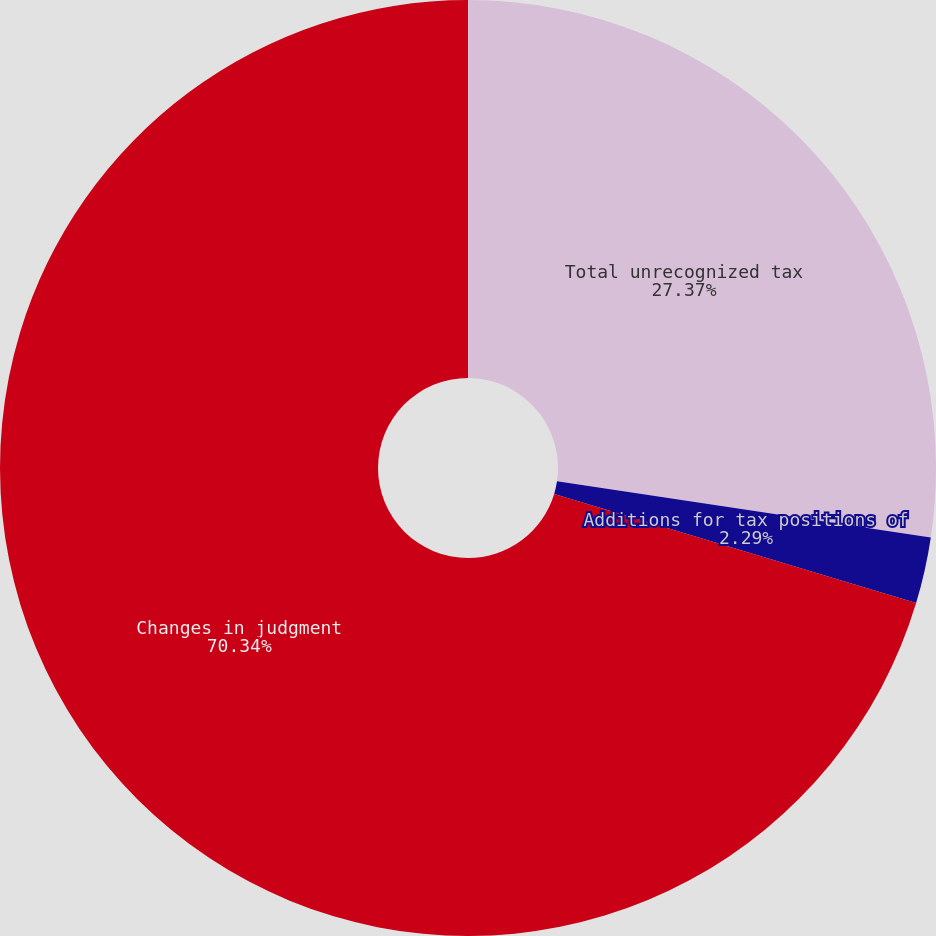Convert chart. <chart><loc_0><loc_0><loc_500><loc_500><pie_chart><fcel>Total unrecognized tax<fcel>Additions for tax positions of<fcel>Changes in judgment<nl><fcel>27.37%<fcel>2.29%<fcel>70.34%<nl></chart> 